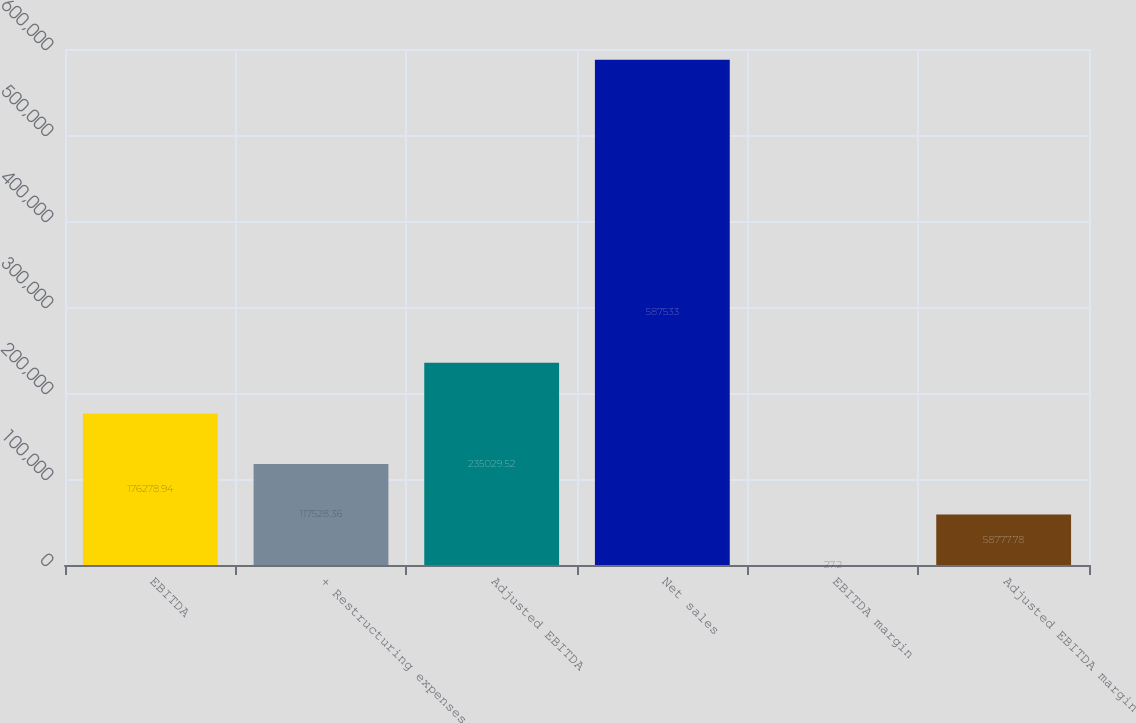<chart> <loc_0><loc_0><loc_500><loc_500><bar_chart><fcel>EBITDA<fcel>+ Restructuring expenses<fcel>Adjusted EBITDA<fcel>Net sales<fcel>EBITDA margin<fcel>Adjusted EBITDA margin<nl><fcel>176279<fcel>117528<fcel>235030<fcel>587533<fcel>27.2<fcel>58777.8<nl></chart> 